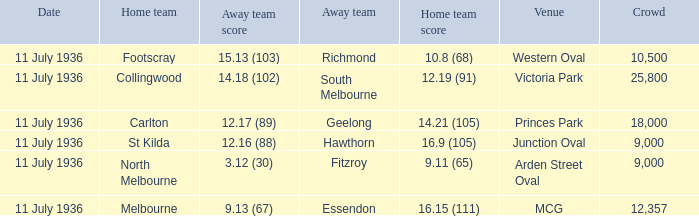What Away team got a team score of 12.16 (88)? Hawthorn. 